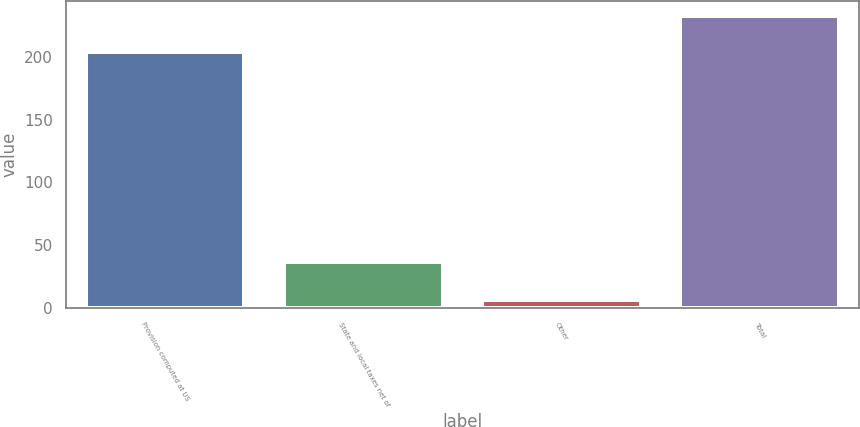<chart> <loc_0><loc_0><loc_500><loc_500><bar_chart><fcel>Provision computed at US<fcel>State and local taxes net of<fcel>Other<fcel>Total<nl><fcel>203.8<fcel>36.9<fcel>6.2<fcel>232.5<nl></chart> 